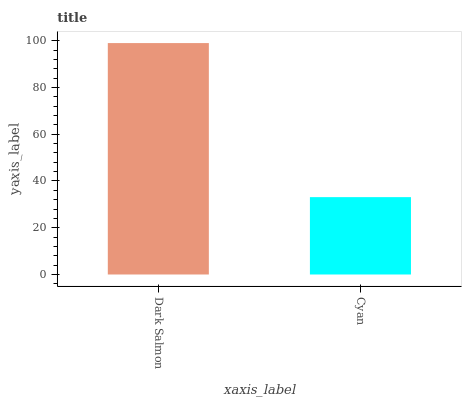Is Cyan the maximum?
Answer yes or no. No. Is Dark Salmon greater than Cyan?
Answer yes or no. Yes. Is Cyan less than Dark Salmon?
Answer yes or no. Yes. Is Cyan greater than Dark Salmon?
Answer yes or no. No. Is Dark Salmon less than Cyan?
Answer yes or no. No. Is Dark Salmon the high median?
Answer yes or no. Yes. Is Cyan the low median?
Answer yes or no. Yes. Is Cyan the high median?
Answer yes or no. No. Is Dark Salmon the low median?
Answer yes or no. No. 